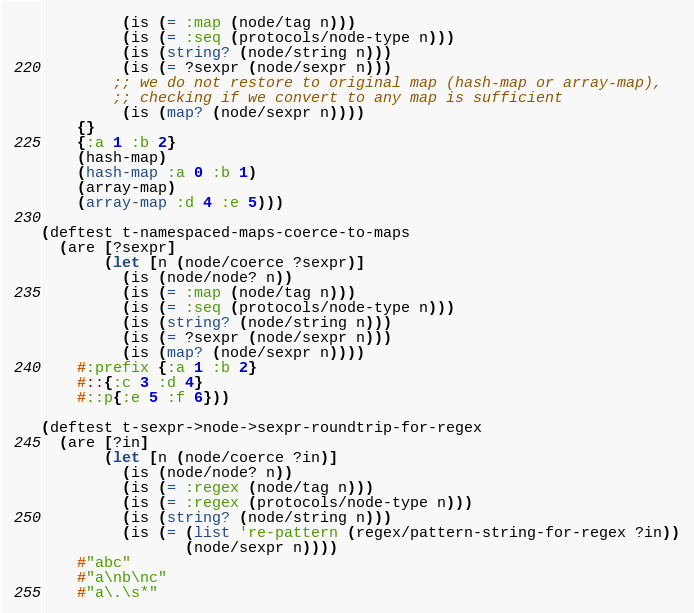<code> <loc_0><loc_0><loc_500><loc_500><_Clojure_>         (is (= :map (node/tag n)))
         (is (= :seq (protocols/node-type n)))
         (is (string? (node/string n)))
         (is (= ?sexpr (node/sexpr n)))
        ;; we do not restore to original map (hash-map or array-map),
        ;; checking if we convert to any map is sufficient
         (is (map? (node/sexpr n))))
    {}
    {:a 1 :b 2}
    (hash-map)
    (hash-map :a 0 :b 1)
    (array-map)
    (array-map :d 4 :e 5)))

(deftest t-namespaced-maps-coerce-to-maps
  (are [?sexpr]
       (let [n (node/coerce ?sexpr)]
         (is (node/node? n))
         (is (= :map (node/tag n)))
         (is (= :seq (protocols/node-type n)))
         (is (string? (node/string n)))
         (is (= ?sexpr (node/sexpr n)))
         (is (map? (node/sexpr n))))
    #:prefix {:a 1 :b 2}
    #::{:c 3 :d 4}
    #::p{:e 5 :f 6}))

(deftest t-sexpr->node->sexpr-roundtrip-for-regex
  (are [?in]
       (let [n (node/coerce ?in)]
         (is (node/node? n))
         (is (= :regex (node/tag n)))
         (is (= :regex (protocols/node-type n)))
         (is (string? (node/string n)))
         (is (= (list 're-pattern (regex/pattern-string-for-regex ?in))
                (node/sexpr n))))
    #"abc"
    #"a\nb\nc"
    #"a\.\s*"</code> 